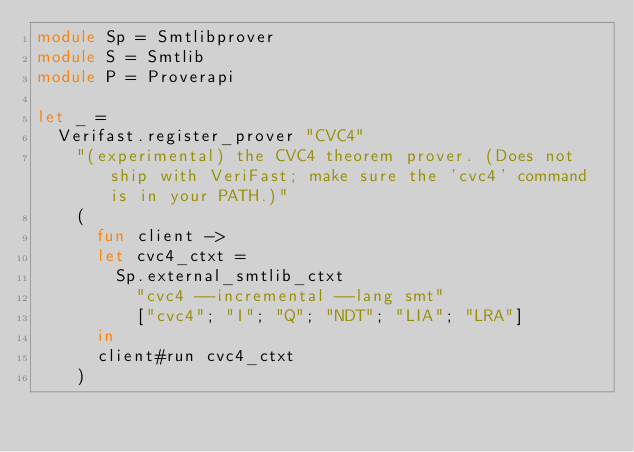Convert code to text. <code><loc_0><loc_0><loc_500><loc_500><_OCaml_>module Sp = Smtlibprover
module S = Smtlib
module P = Proverapi

let _ =
  Verifast.register_prover "CVC4"
    "(experimental) the CVC4 theorem prover. (Does not ship with VeriFast; make sure the 'cvc4' command is in your PATH.)"
    (
      fun client ->
      let cvc4_ctxt =
        Sp.external_smtlib_ctxt
          "cvc4 --incremental --lang smt"
          ["cvc4"; "I"; "Q"; "NDT"; "LIA"; "LRA"]
      in
      client#run cvc4_ctxt
    )
</code> 